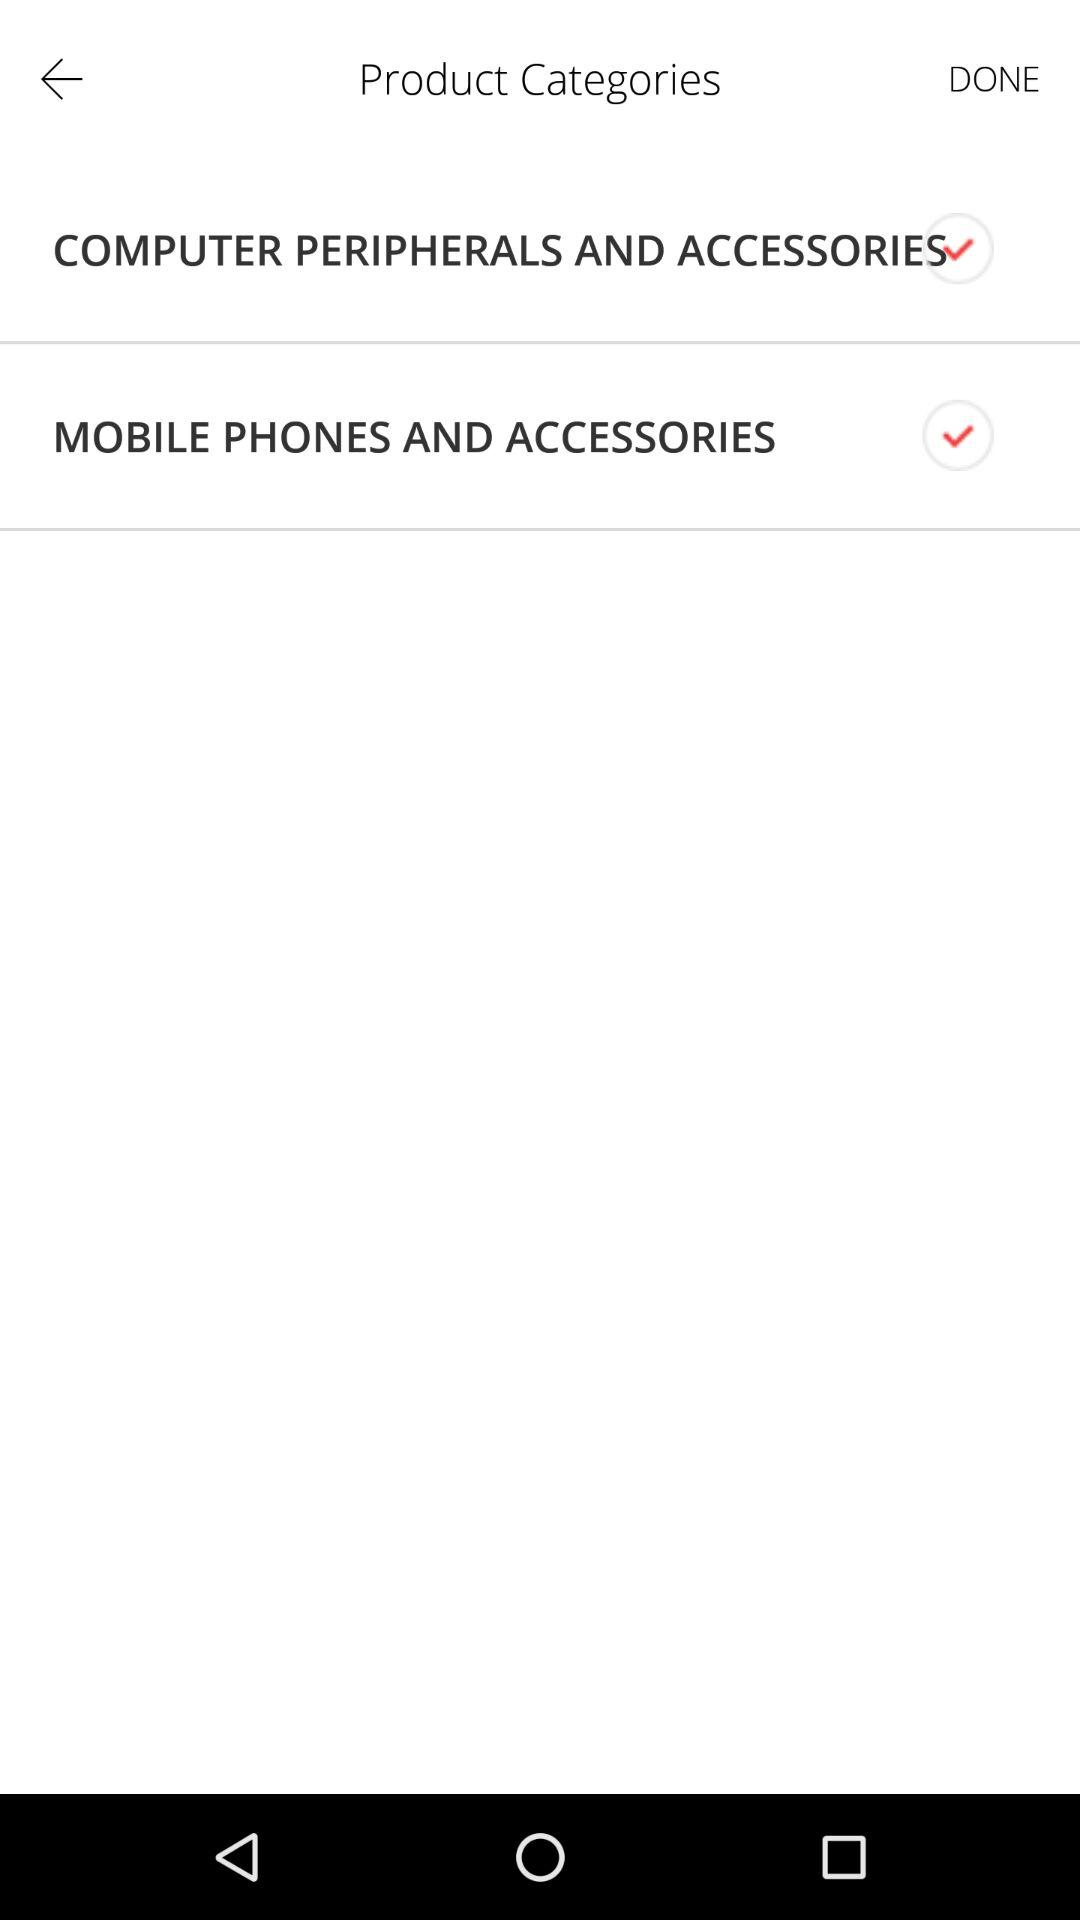What is the current status of "MOBILE PHONES AND ACCESSORIES"? The current status is "on". 